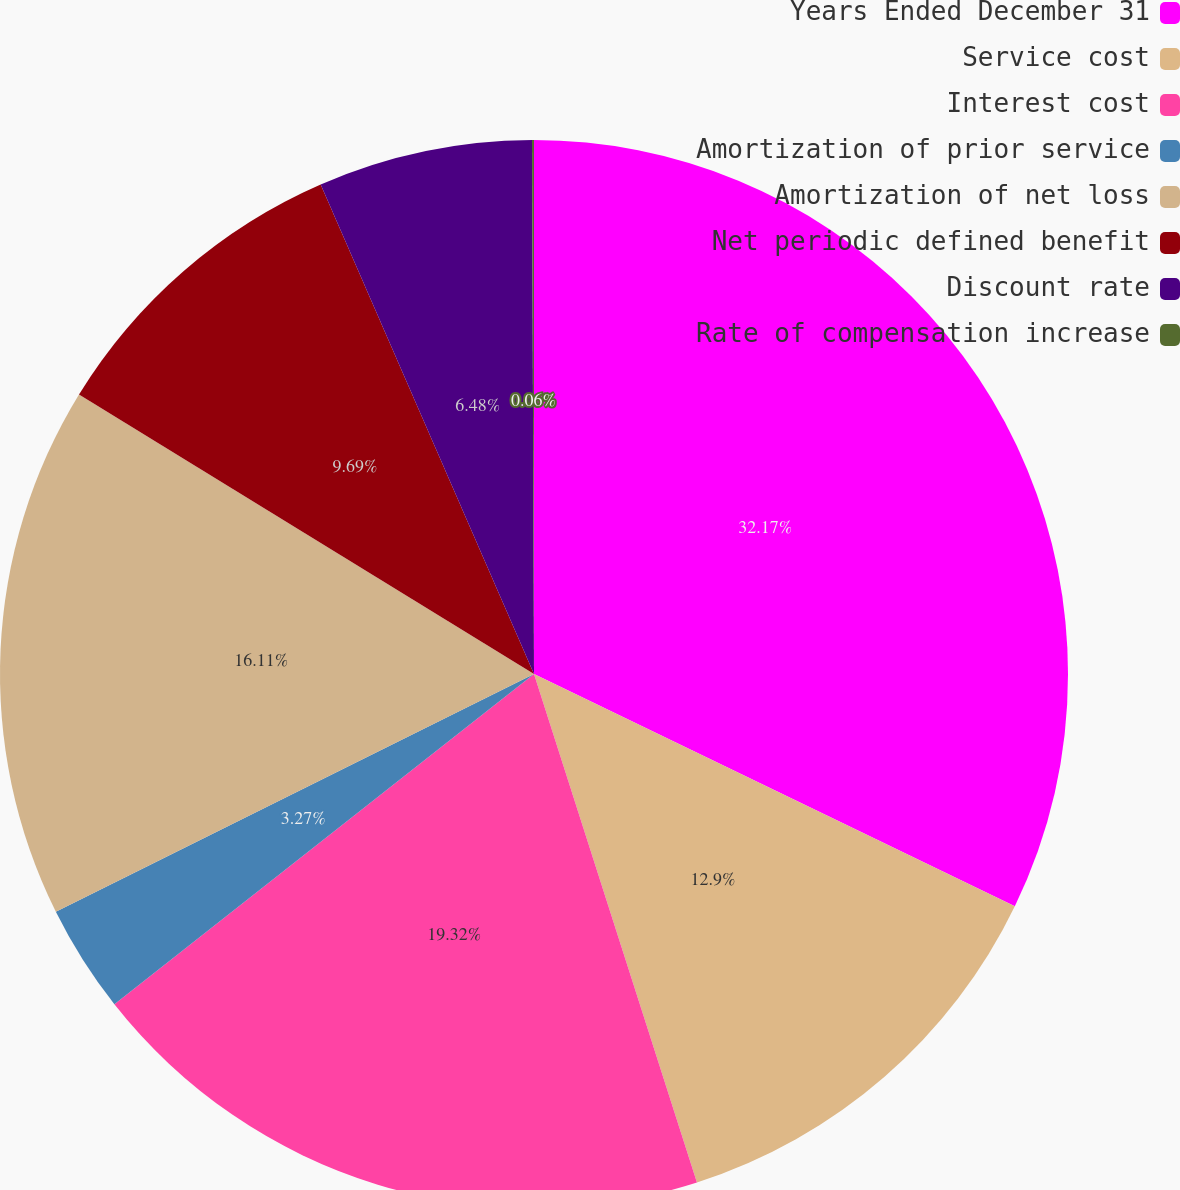Convert chart. <chart><loc_0><loc_0><loc_500><loc_500><pie_chart><fcel>Years Ended December 31<fcel>Service cost<fcel>Interest cost<fcel>Amortization of prior service<fcel>Amortization of net loss<fcel>Net periodic defined benefit<fcel>Discount rate<fcel>Rate of compensation increase<nl><fcel>32.16%<fcel>12.9%<fcel>19.32%<fcel>3.27%<fcel>16.11%<fcel>9.69%<fcel>6.48%<fcel>0.06%<nl></chart> 